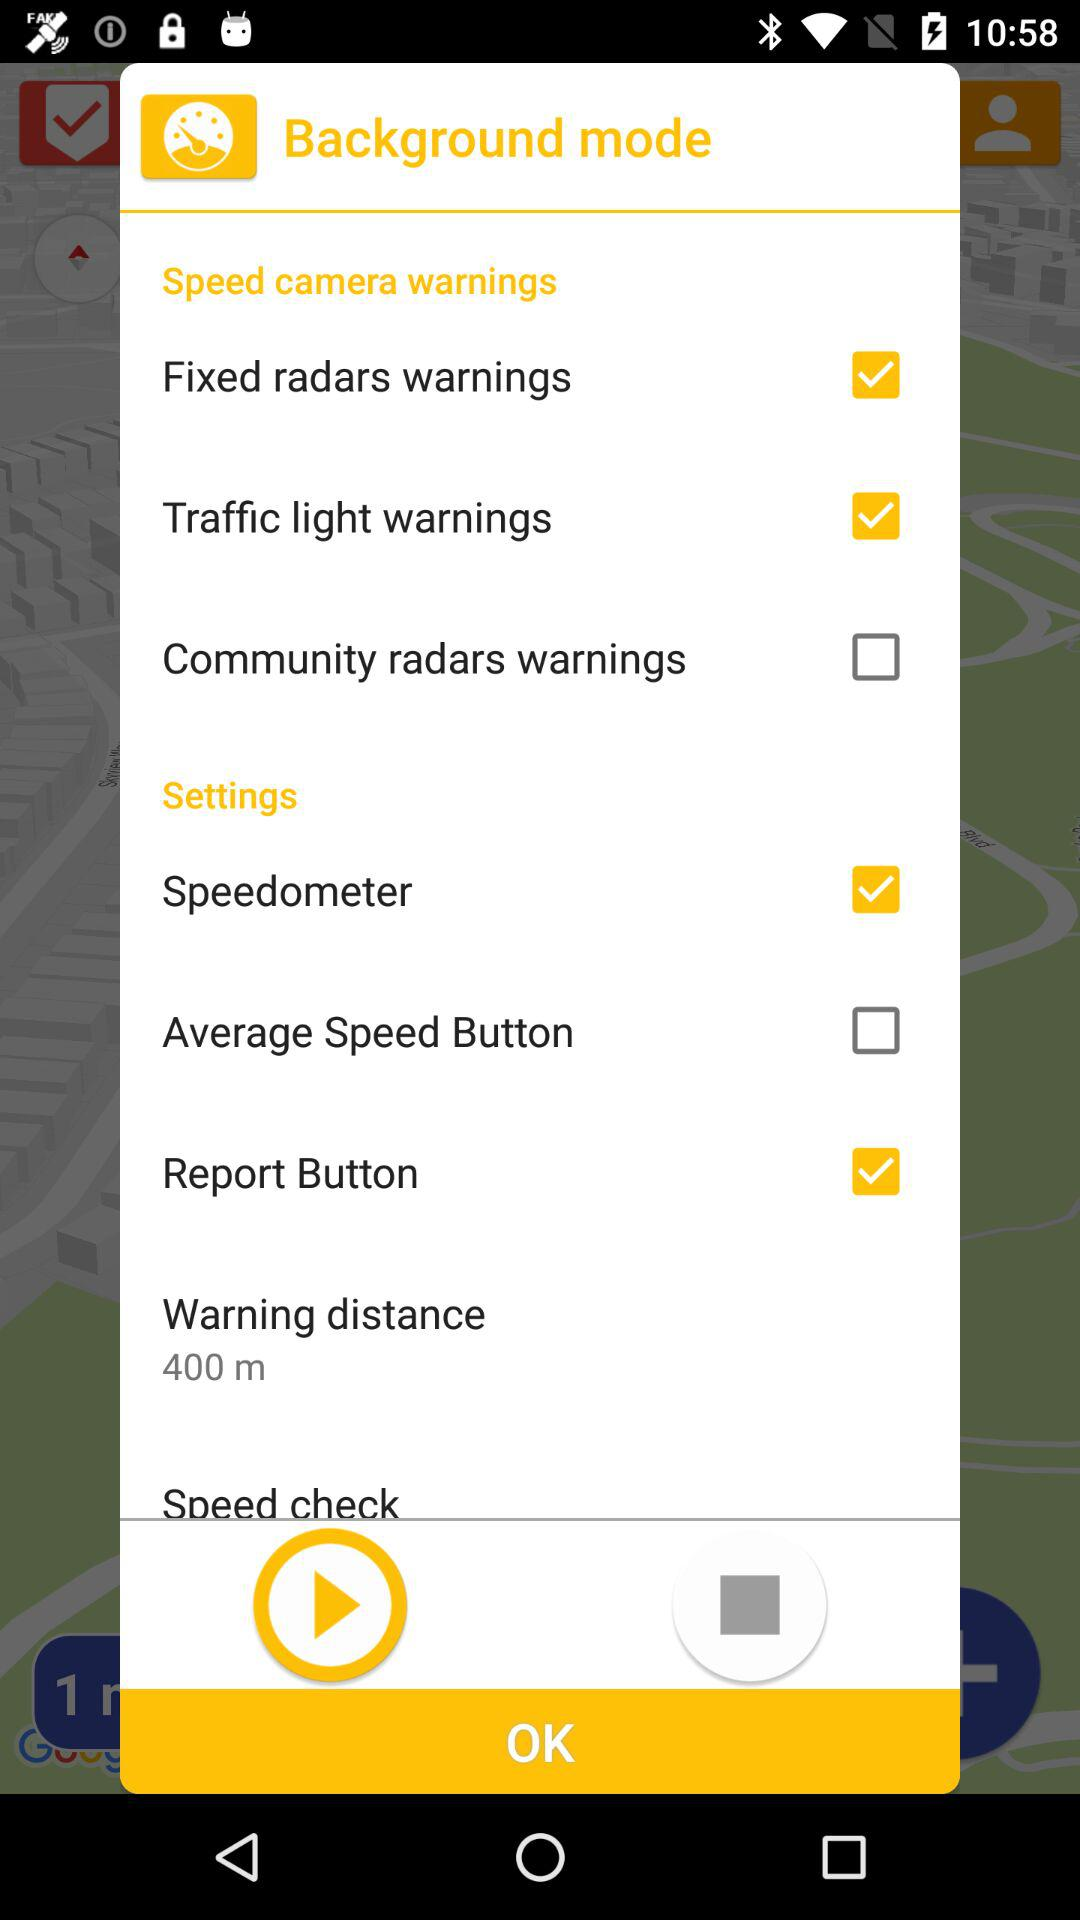What is the 'Average Speed Button' and is it turned on? The 'Average Speed Button' seems to be an additional setting probably related to monitoring or displaying your average speed while driving. It's a helpful feature for staying within speed limits, especially in areas with average speed checks. In this image, the option for 'Average Speed Button' is not selected, which indicates that it's currently turned off. 